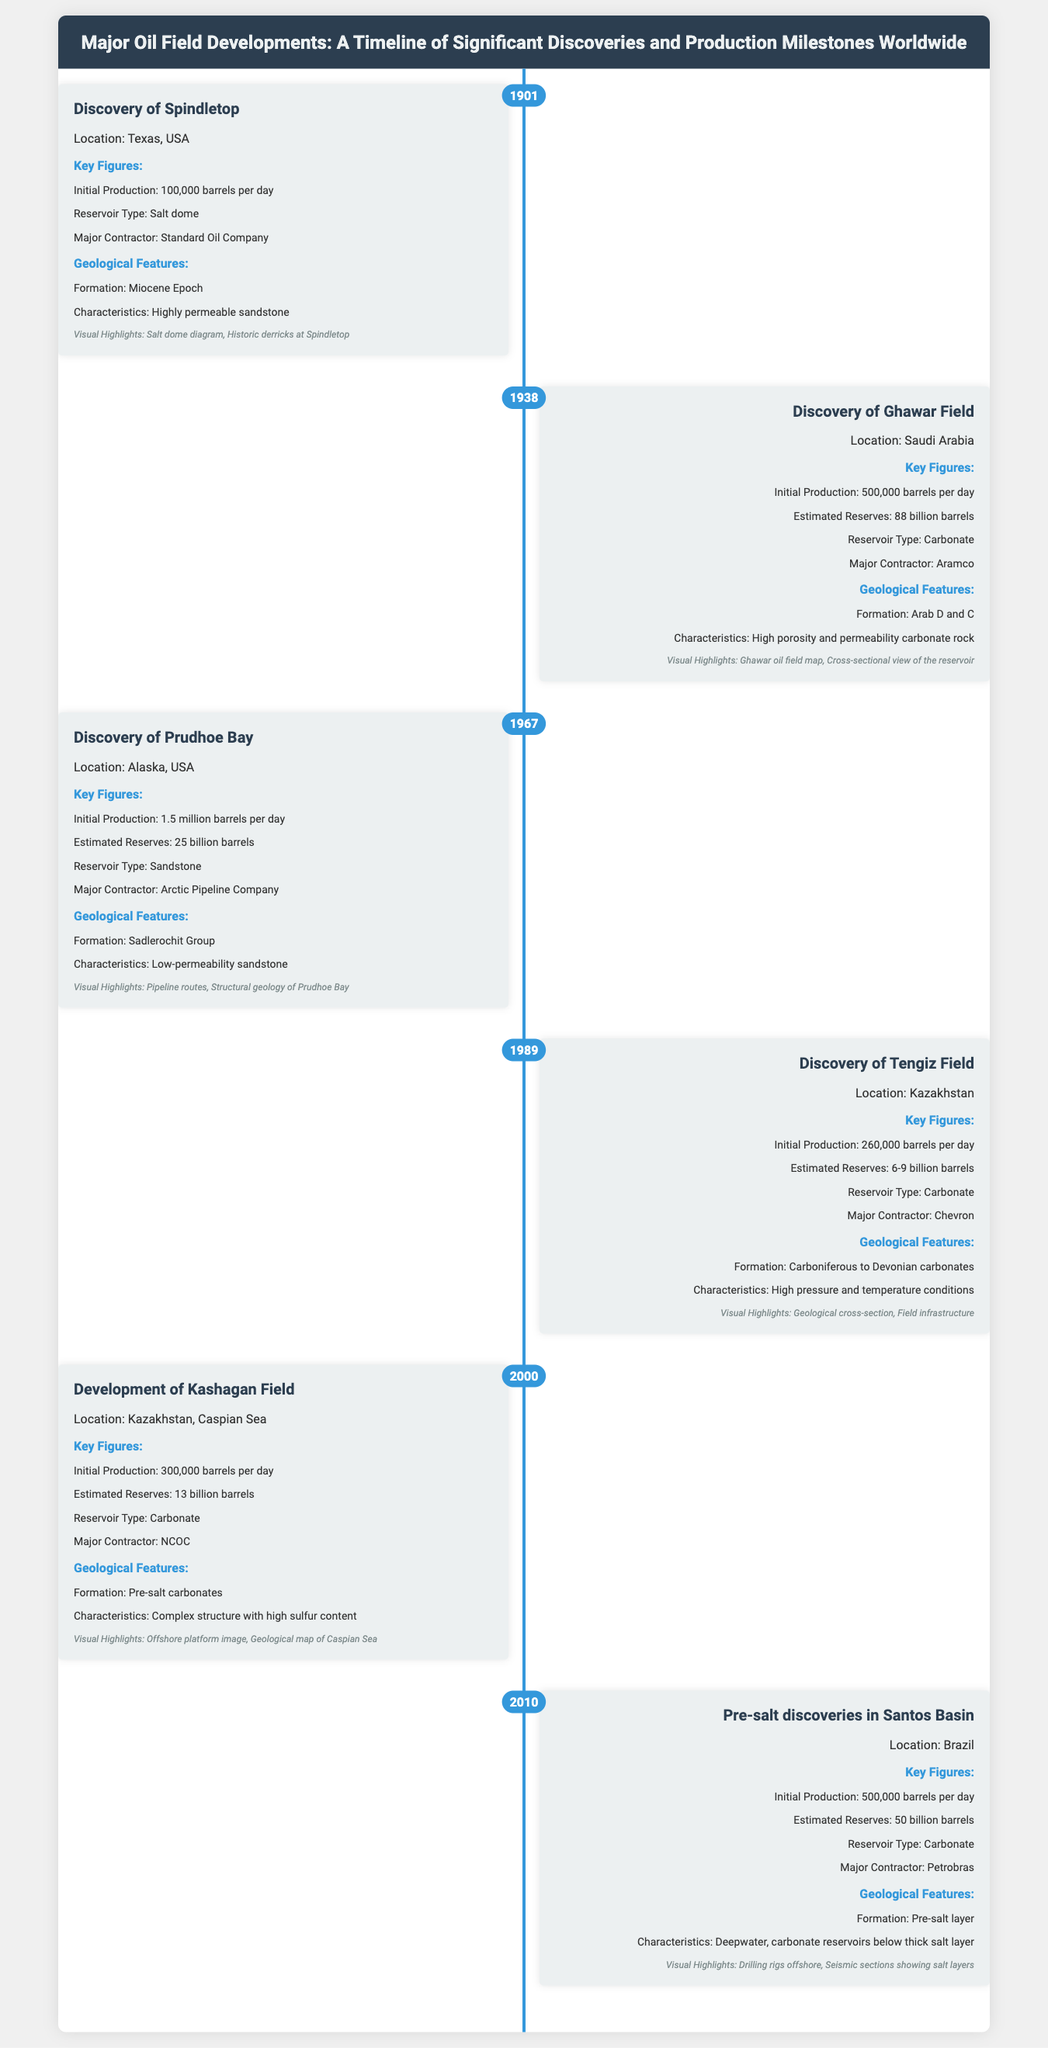What year was the Discovery of Spindletop? The document shows that the Discovery of Spindletop occurred in the year 1901.
Answer: 1901 What is the Initial Production of Ghawar Field? The document indicates that the Initial Production of Ghawar Field is 500,000 barrels per day.
Answer: 500,000 barrels per day What reservoir type is associated with Prudhoe Bay? According to the document, Prudhoe Bay is classified as a Sandstone reservoir type.
Answer: Sandstone What are the Estimated Reserves of the Kashagan Field? The Estimated Reserves of the Kashagan Field mentioned in the document is 13 billion barrels.
Answer: 13 billion barrels What geological formation is the Ghawar Field associated with? The document states that the Ghawar Field is associated with the Arab D and C formation.
Answer: Arab D and C How many barrels per day was the Initial Production of Tengiz Field? The document reveals that the Initial Production of Tengiz Field was 260,000 barrels per day.
Answer: 260,000 barrels per day Which field is known for deepwater carbonate reservoirs below a thick salt layer? The document notes that the Pre-salt discoveries in Santos Basin are known for such characteristics.
Answer: Pre-salt discoveries in Santos Basin What major contractor is associated with the development of Kashagan Field? The document identifies NCOC as the major contractor for the development of Kashagan Field.
Answer: NCOC Which oil field discovery occurred in 1967? According to the document, the Discovery of Prudhoe Bay occurred in 1967.
Answer: Prudhoe Bay 